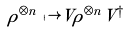<formula> <loc_0><loc_0><loc_500><loc_500>\rho ^ { \otimes n } \mapsto V \rho ^ { \otimes n } V ^ { \dagger }</formula> 